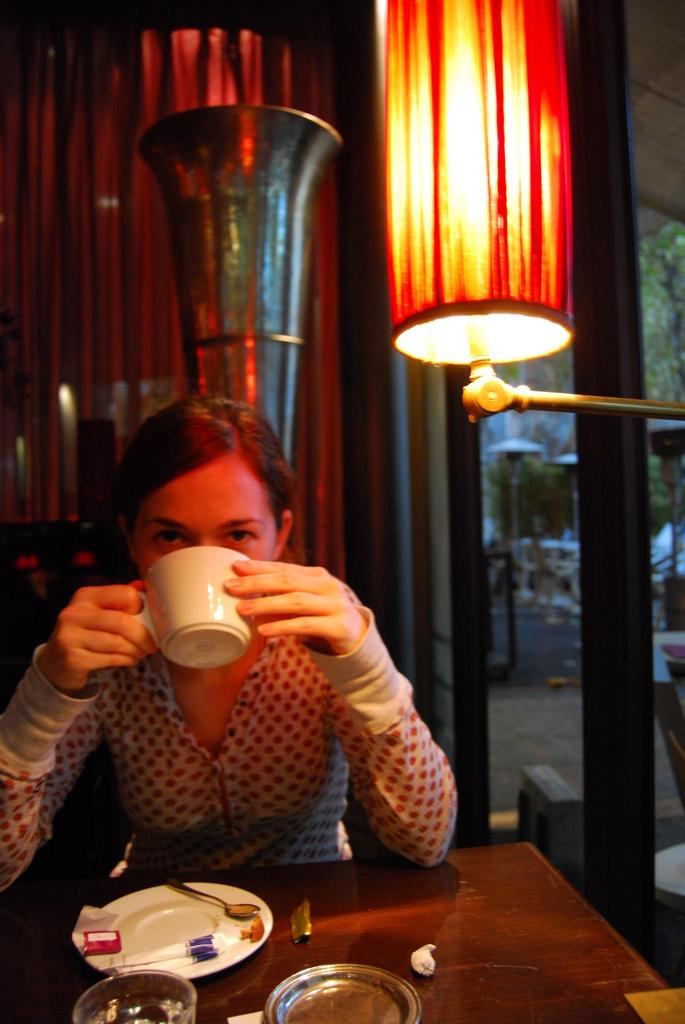Who is present in the image? There is a woman in the image. What is the woman doing in the image? The woman is sitting and drinking something. What is on the table in the image? There is a plate on the table. What can be seen in the image that provides light? There is a light in the image. What is visible in the image that allows natural light to enter? There are windows in the image. What type of canvas is the woman painting in the image? There is no canvas or painting activity present in the image. What color is the copper pot on the table in the image? There is no copper pot on the table in the image. 